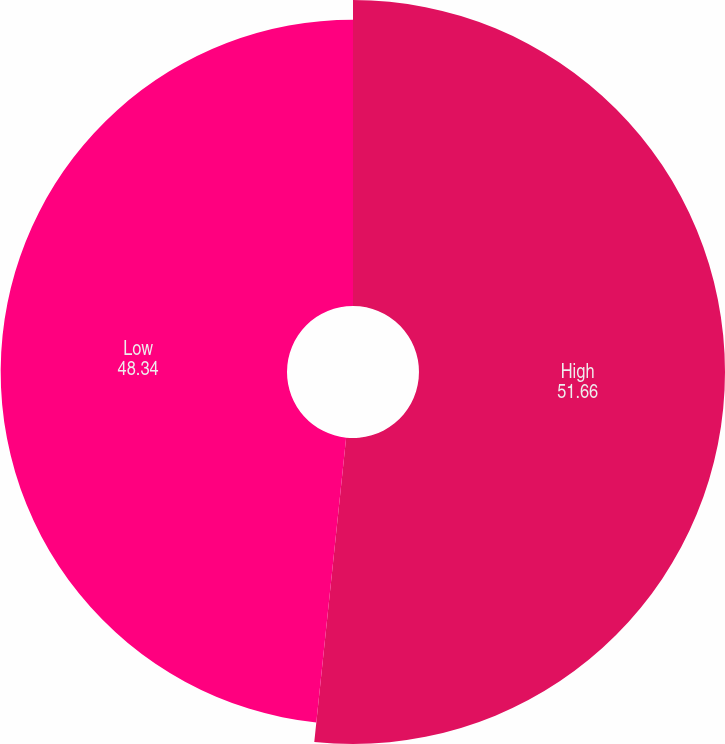<chart> <loc_0><loc_0><loc_500><loc_500><pie_chart><fcel>High<fcel>Low<nl><fcel>51.66%<fcel>48.34%<nl></chart> 